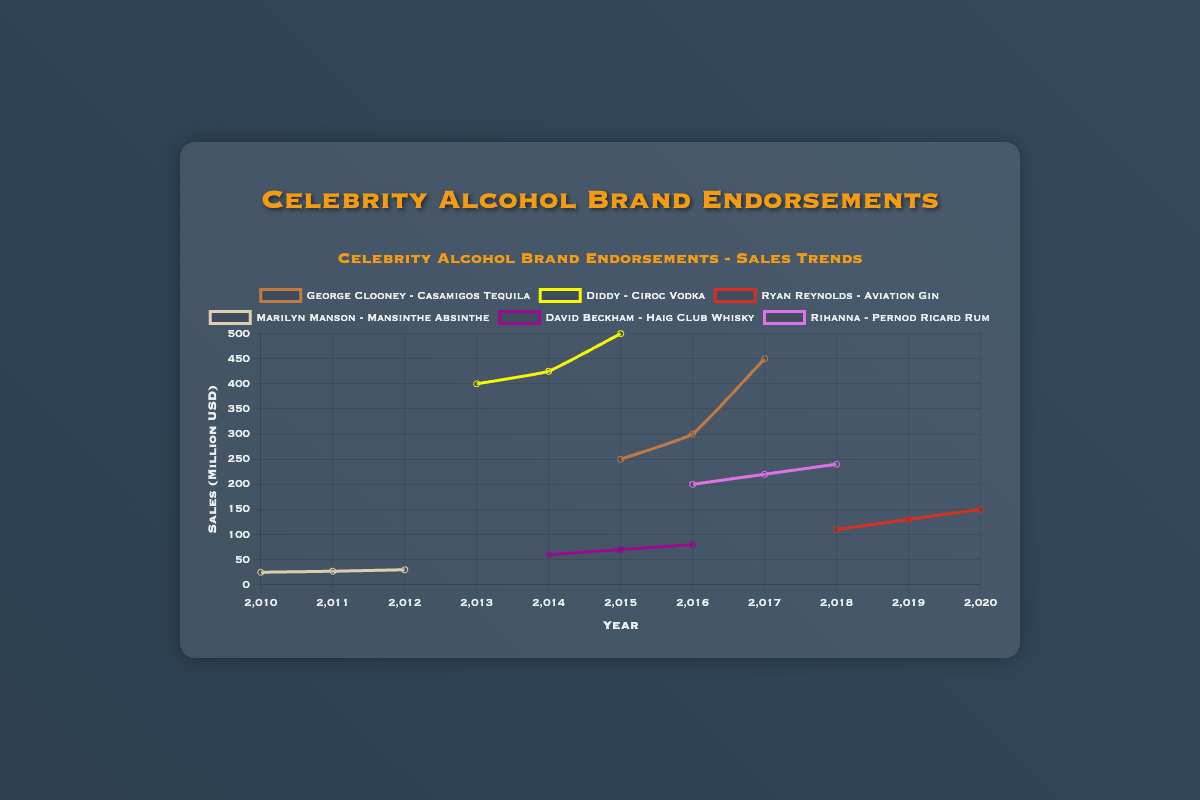What is the highest recorded sales figure and which celebrity and brand does it belong to? Looking at the peak of all lines on the chart, we can observe that the highest sales figure is $500 million. The label connected to this peak indicates it belongs to Diddy with Ciroc Vodka in 2015.
Answer: Diddy with Ciroc Vodka in 2015 What is the average annual sales growth for George Clooney's Casamigos Tequila from 2015 to 2017? To find the average annual sales growth, first calculate the difference in sales between the years: (300-250) for 2016 and (450-300) for 2017, which are 50 and 150 respectively. Then, average these differences: (50+150)/2 = 100. So, the average annual sales growth is $100 million per year.
Answer: $100 million per year Which celebrity’s brand saw the most consistent increase in sales over the periods charted? By examining the graph, Marilyn Manson's Mansinthe Absinthe shows a steady and consistent increase in sales: 25 in 2010, 27 in 2011, and 30 in 2012, demonstrating a continuous upward trend without fluctuations.
Answer: Marilyn Manson Compare the sales growth of David Beckham’s Haig Club Whisky from 2014 to 2016 with Rihanna’s Pernod Ricard Rum from 2016 to 2018. Who had a higher growth rate? Calculate the growth for each. David Beckham's sales grew from 60 to 80 (80-60=20 over 2 years), average annual growth is 20/2=10. Rihanna's sales grew from 200 to 240 (240-200=40 over 2 years), average annual growth is 40/2=20. Therefore, Rihanna had a higher growth rate.
Answer: Rihanna What was the total sales in 2016 for all endorsements displayed on the chart? To find the total sales in 2016, sum sales from each celebrity in 2016: George Clooney (300) + David Beckham (80) + Rihanna (200) = 580. Diddy's and others' data not available for 2016. Thus, the total sales are $580 million.
Answer: $580 million Which endorsement line is visually represented with the color blue on the chart? The blue color line represents the endorsement of Aviation Gin by Ryan Reynolds, as we differentiate based on the visible visual attributes.
Answer: Ryan Reynolds with Aviation Gin Between George Clooney’s Casamigos Tequila and Ryan Reynolds’ Aviation Gin, which endorsement saw a more significant percentage increase in sales over its observed period? Calculate the percentage increase for both: Clooney’s Casamigos Tequila from 250 to 450 yields [(450-250)/250]*100 = 80%. Reynolds’ Aviation Gin from 110 to 150 is [(150-110)/110]*100 = 36.36%. Clooney’s endorsement saw a more significant percentage increase.
Answer: George Clooney with Casamigos Tequila 